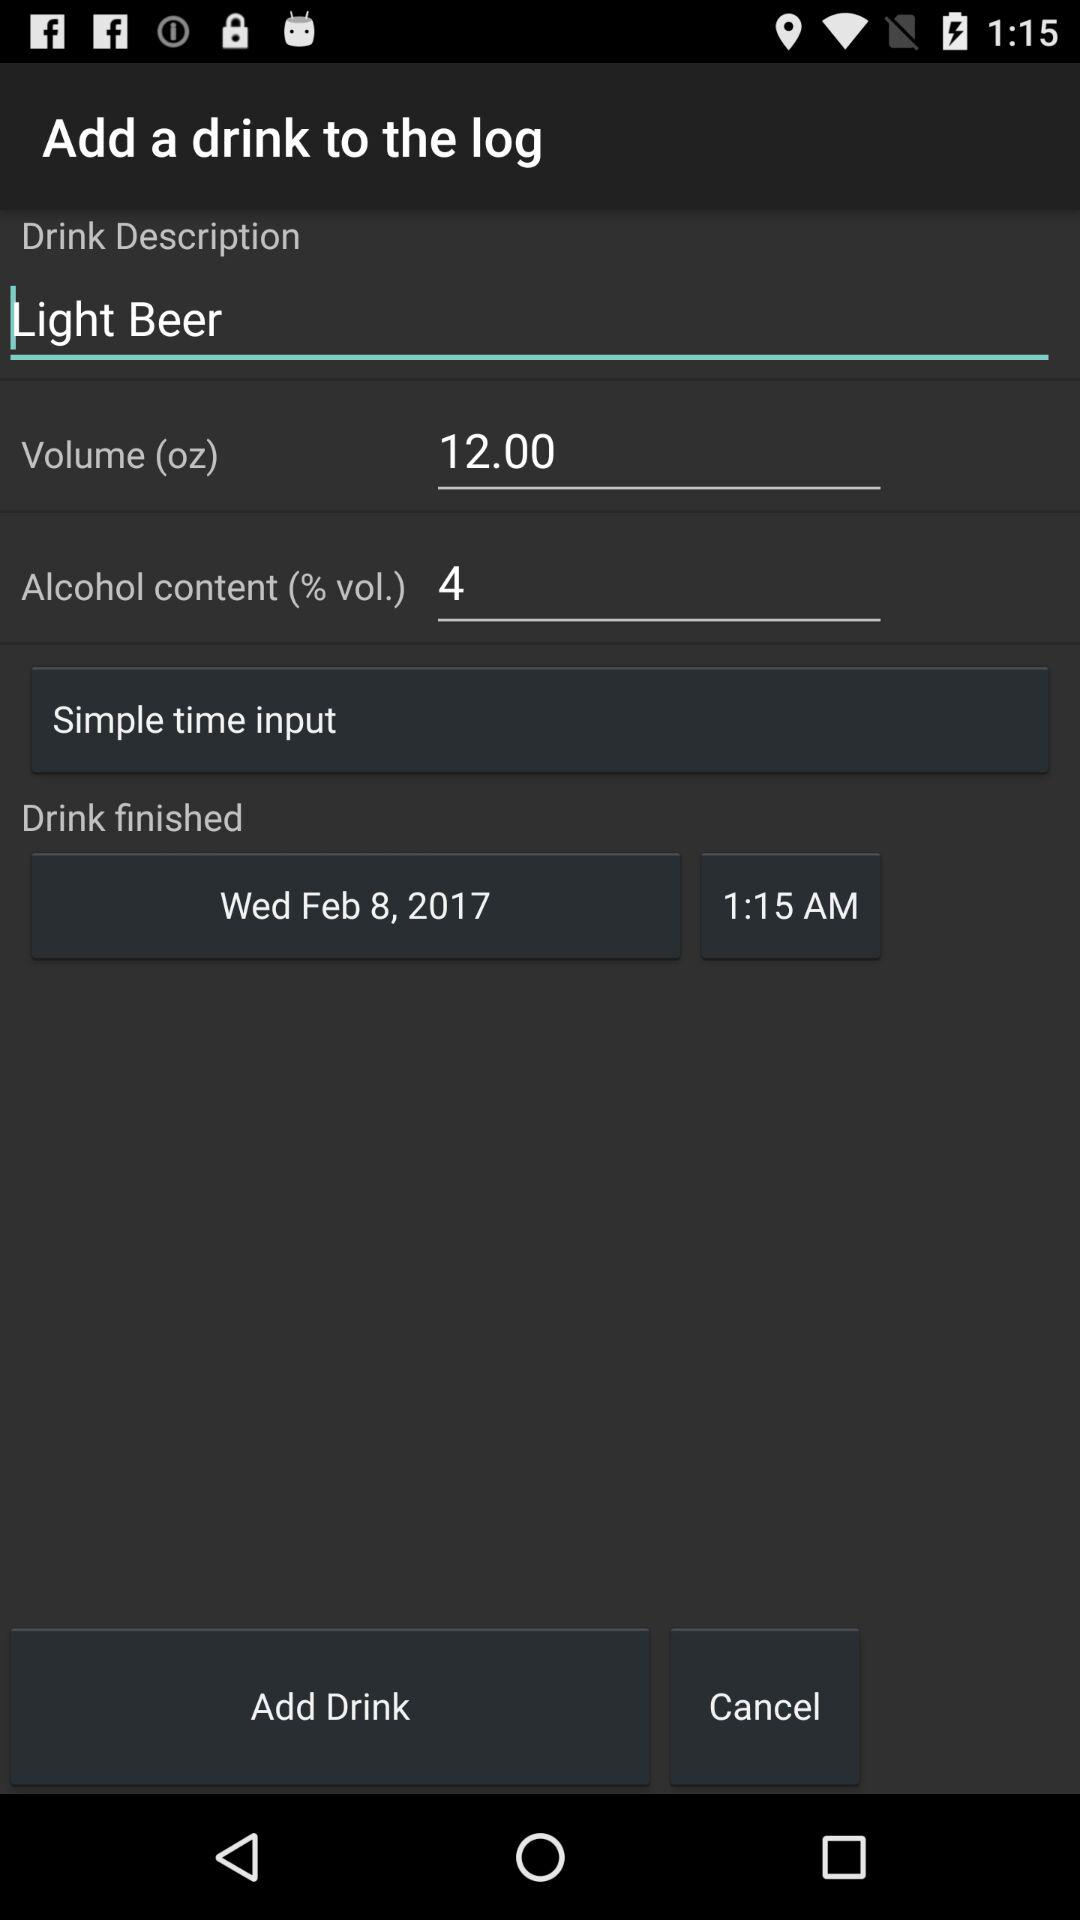What is the unit of volume? The unit of volume is ounces. 